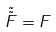<formula> <loc_0><loc_0><loc_500><loc_500>\tilde { \tilde { F } } = F</formula> 